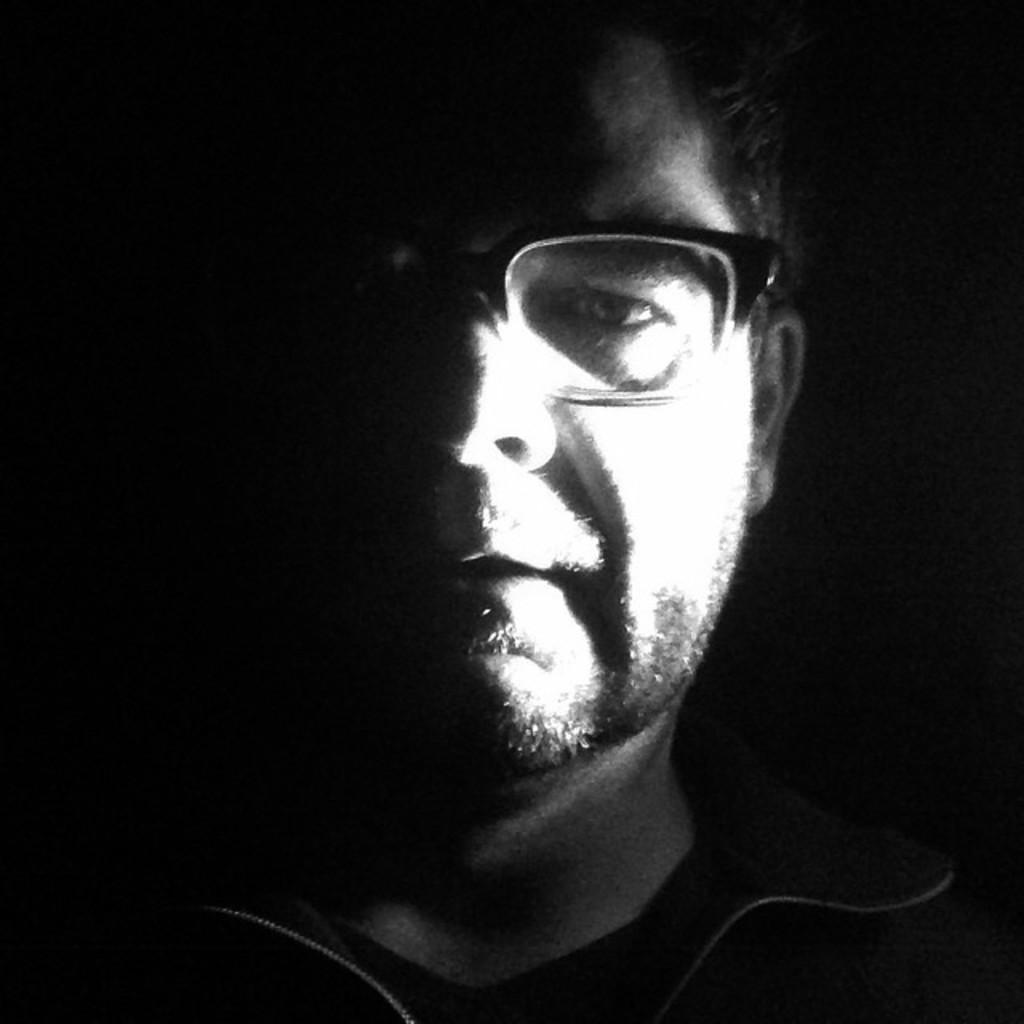Describe this image in one or two sentences. In this picture I can see a man, he is wearing the spectacles, this image is in black and white color. 